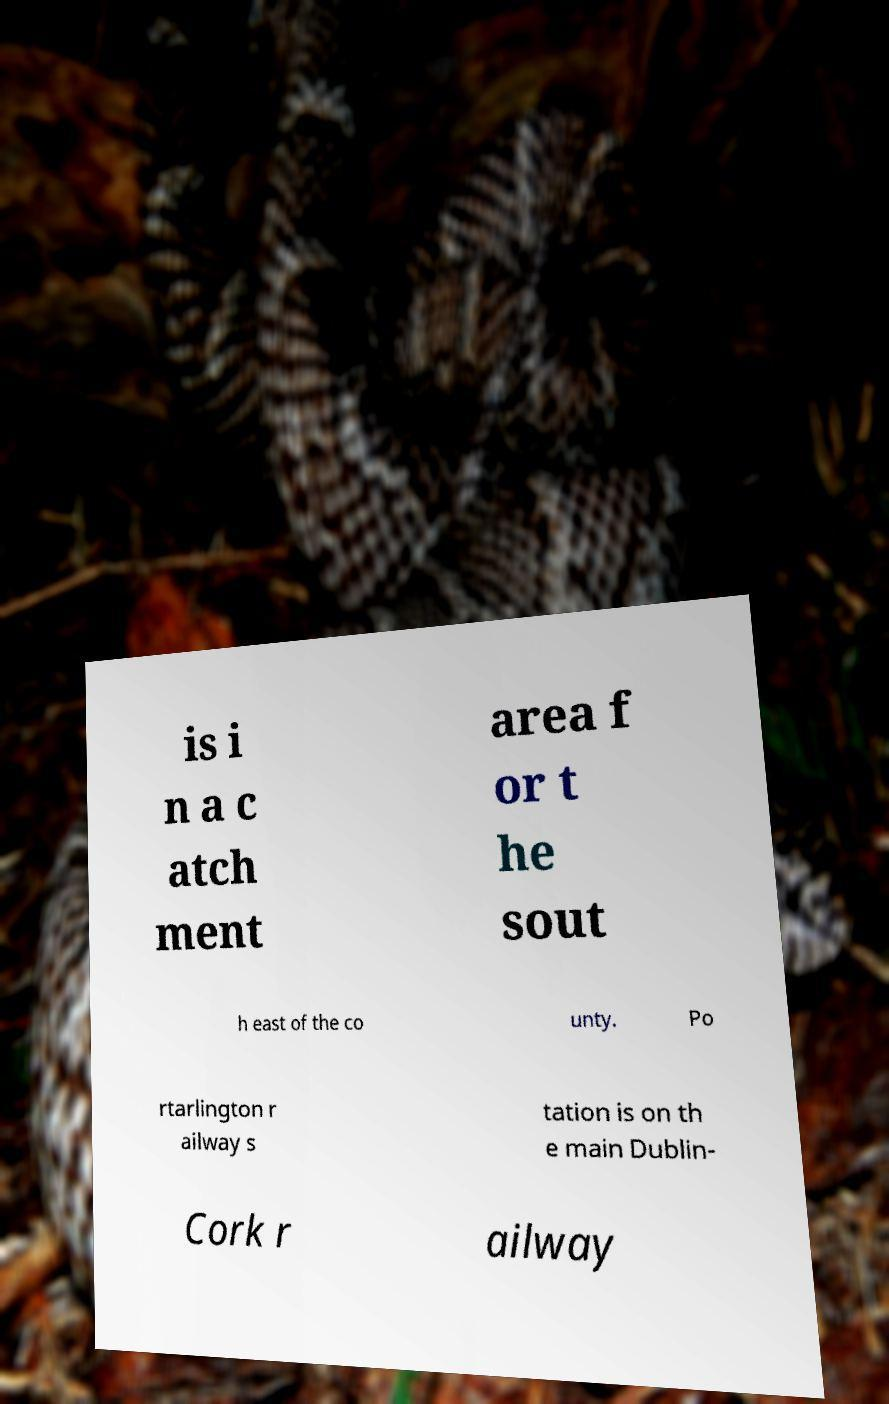I need the written content from this picture converted into text. Can you do that? is i n a c atch ment area f or t he sout h east of the co unty. Po rtarlington r ailway s tation is on th e main Dublin- Cork r ailway 